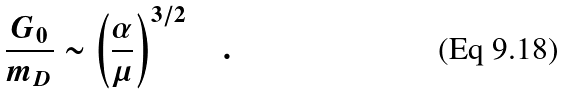<formula> <loc_0><loc_0><loc_500><loc_500>\frac { G _ { 0 } } { m _ { D } } \sim \left ( \frac { \alpha } { \mu } \right ) ^ { 3 / 2 } \quad .</formula> 